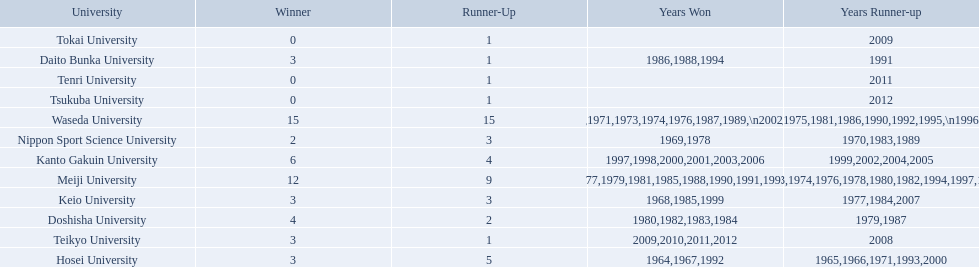What university were there in the all-japan university rugby championship? Waseda University, Meiji University, Kanto Gakuin University, Doshisha University, Hosei University, Keio University, Daito Bunka University, Nippon Sport Science University, Teikyo University, Tokai University, Tenri University, Tsukuba University. Of these who had more than 12 wins? Waseda University. 